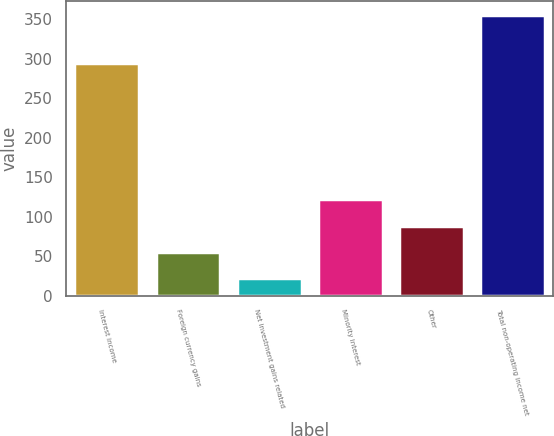<chart> <loc_0><loc_0><loc_500><loc_500><bar_chart><fcel>Interest income<fcel>Foreign currency gains<fcel>Net investment gains related<fcel>Minority interest<fcel>Other<fcel>Total non-operating income net<nl><fcel>295<fcel>55.3<fcel>22<fcel>121.9<fcel>88.6<fcel>355<nl></chart> 